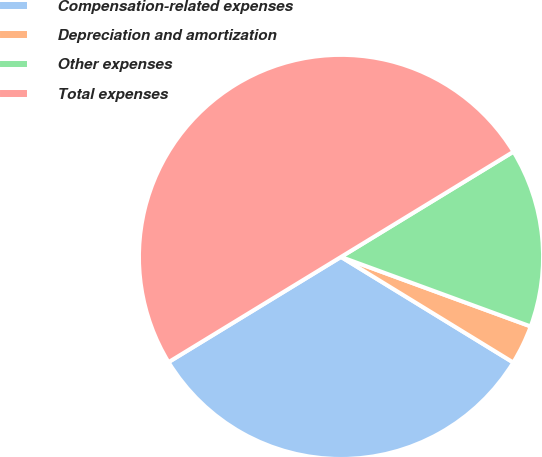Convert chart to OTSL. <chart><loc_0><loc_0><loc_500><loc_500><pie_chart><fcel>Compensation-related expenses<fcel>Depreciation and amortization<fcel>Other expenses<fcel>Total expenses<nl><fcel>32.53%<fcel>3.16%<fcel>14.31%<fcel>50.0%<nl></chart> 